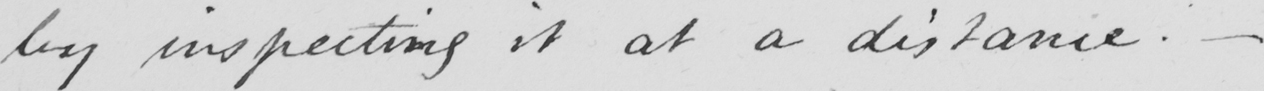Can you read and transcribe this handwriting? by inspecting it at a distance . _ 